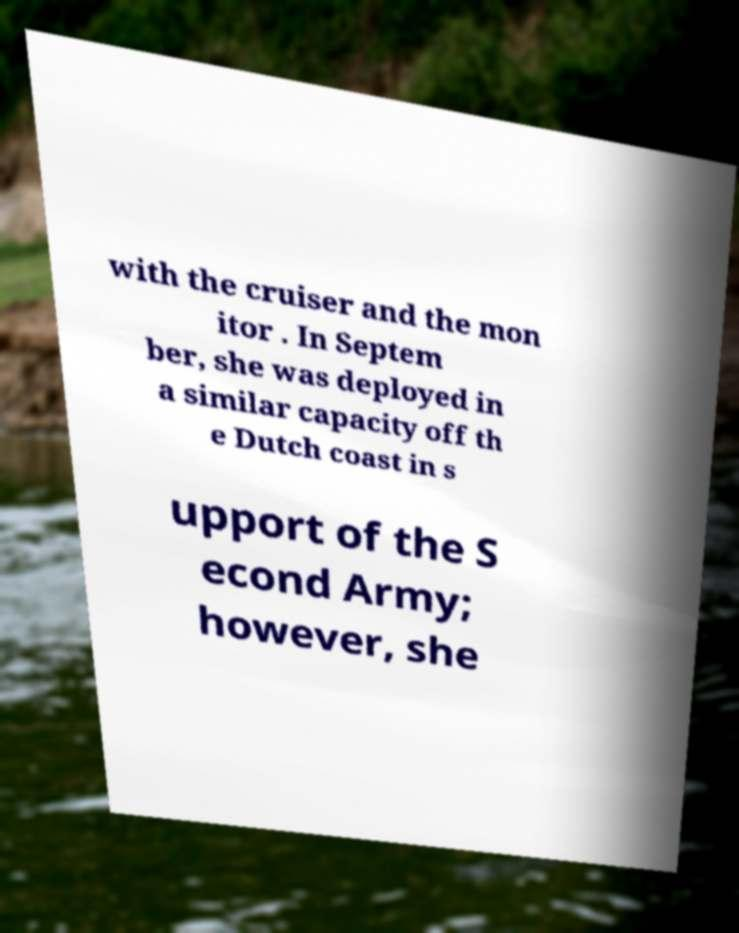Could you extract and type out the text from this image? with the cruiser and the mon itor . In Septem ber, she was deployed in a similar capacity off th e Dutch coast in s upport of the S econd Army; however, she 